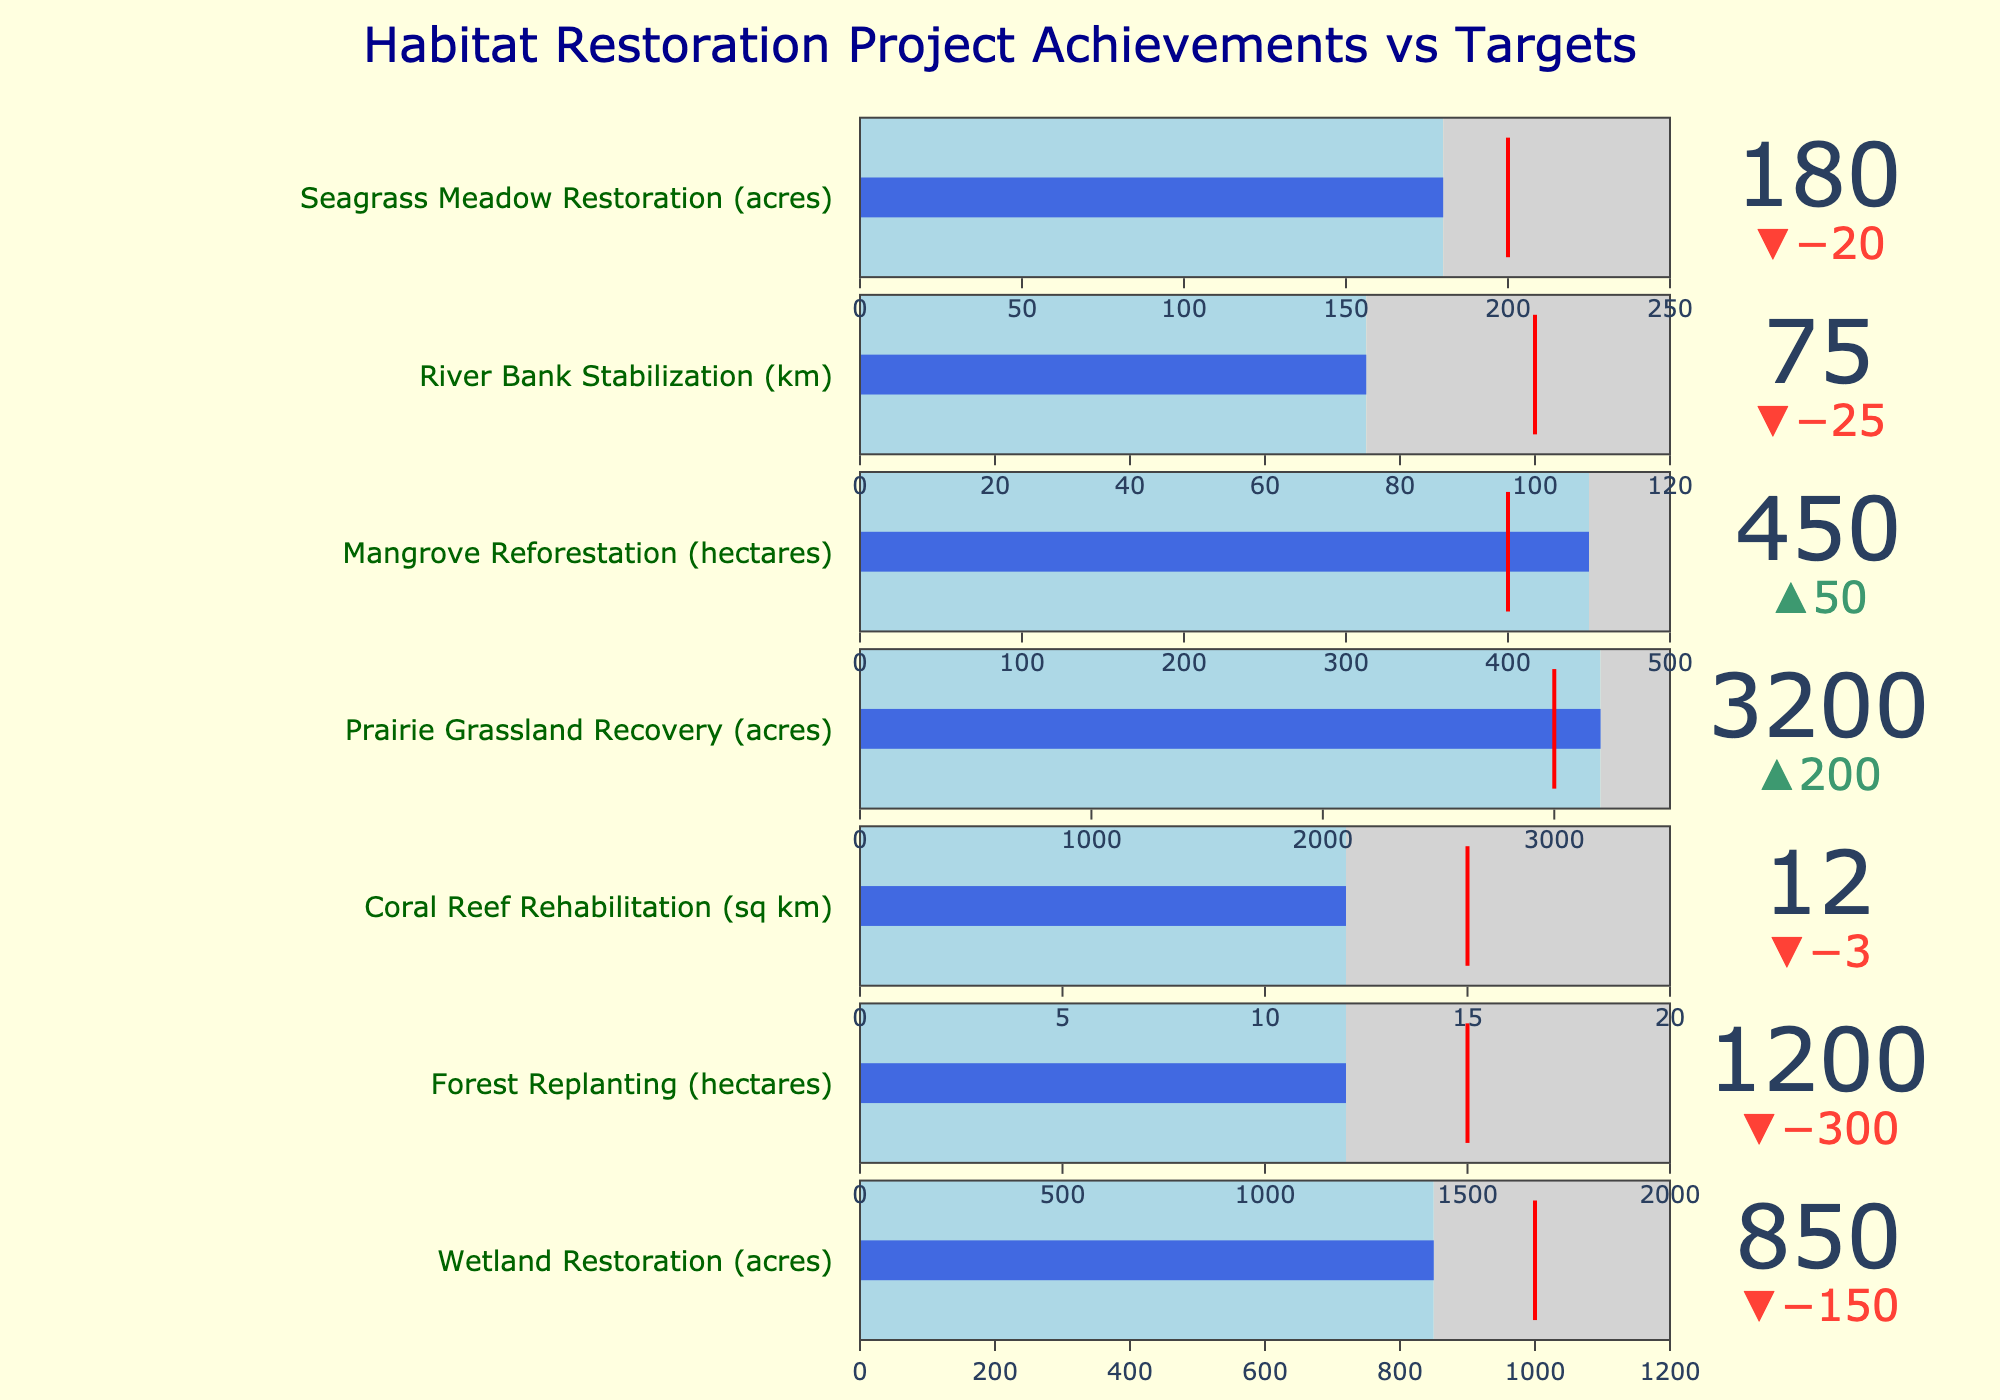How many projects are listed in the bullet chart? To find the number of projects, count the distinct titles of the projects shown in the bullet chart.
Answer: 7 What is the title of the chart? The title is usually displayed prominently at the top of the chart.
Answer: Habitat Restoration Project Achievements vs Targets Compare the actual and target achievements for Seagrass Meadow Restoration. Is it above or below the target? Look for the "Seagrass Meadow Restoration" project and compare its actual (180 acres) against its target (200 acres). If the actual is less than the target, it is below.
Answer: Below Which project has the highest actual achievement? Compare the "Actual" values of all projects and identify the one with the highest number.
Answer: Prairie Grassland Recovery What is the difference between the actual and target values for Mangrove Reforestation? Subtract the target value (400 hectares) from the actual value (450 hectares) for the Mangrove Reforestation project.
Answer: 50 hectares How many projects exceeded their targets? Compare the actual and target values for each project. Count how many projects have actual values greater than their target values.
Answer: 2 What is the average actual achievement across all projects? Add the actual values of all projects and divide by the number of projects. The values are: 850 + 1200 + 12 + 3200 + 450 + 75 + 180. Sum these and divide by 7.
Answer: 995.29 Which project is closest to meeting its target? Calculate the absolute differences between the actual values and target values for each project. Identify the project with the smallest difference. The differences are: 150, 300, 3, 200, 50, 25, 20.
Answer: Seagrass Meadow Restoration Is there any project whose maximum potential (Maximum) is exactly equal to its actual achievement? Compare the "Maximum" and "Actual" values for each project to see if any match precisely.
Answer: No What is the cumulative target achievement for Wetland Restoration and Forest Replanting? Add the target values of Wetland Restoration (1000 acres) and Forest Replanting (1500 hectares).
Answer: 2500 